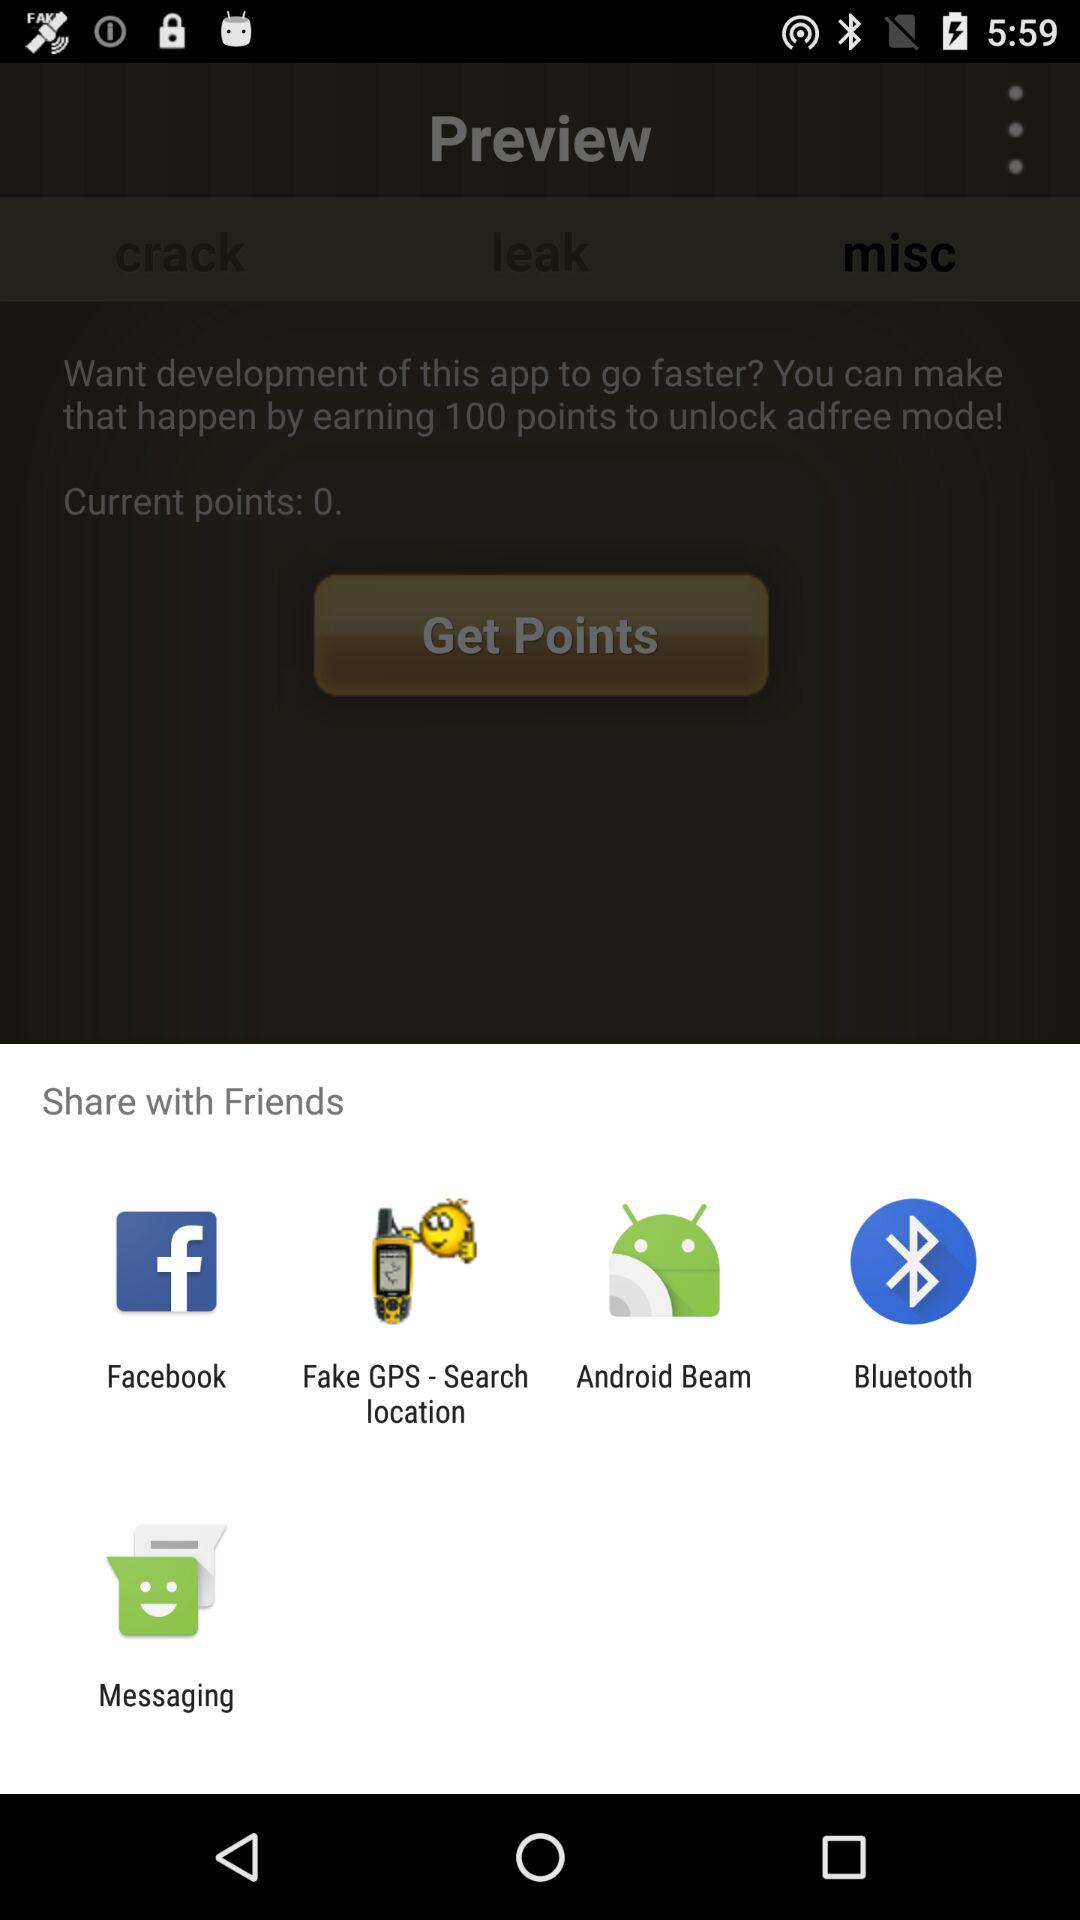What are the different applications through which we can share? The different applications through which you can share are "Facebook", "Fake GPS - Search location", "Android Beam", "Bluetooth" and "Messaging". 